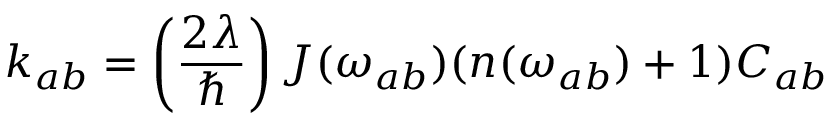<formula> <loc_0><loc_0><loc_500><loc_500>k _ { a b } = \left ( \frac { 2 \lambda } { } \right ) J ( \omega _ { a b } ) ( n ( \omega _ { a b } ) + 1 ) C _ { a b }</formula> 